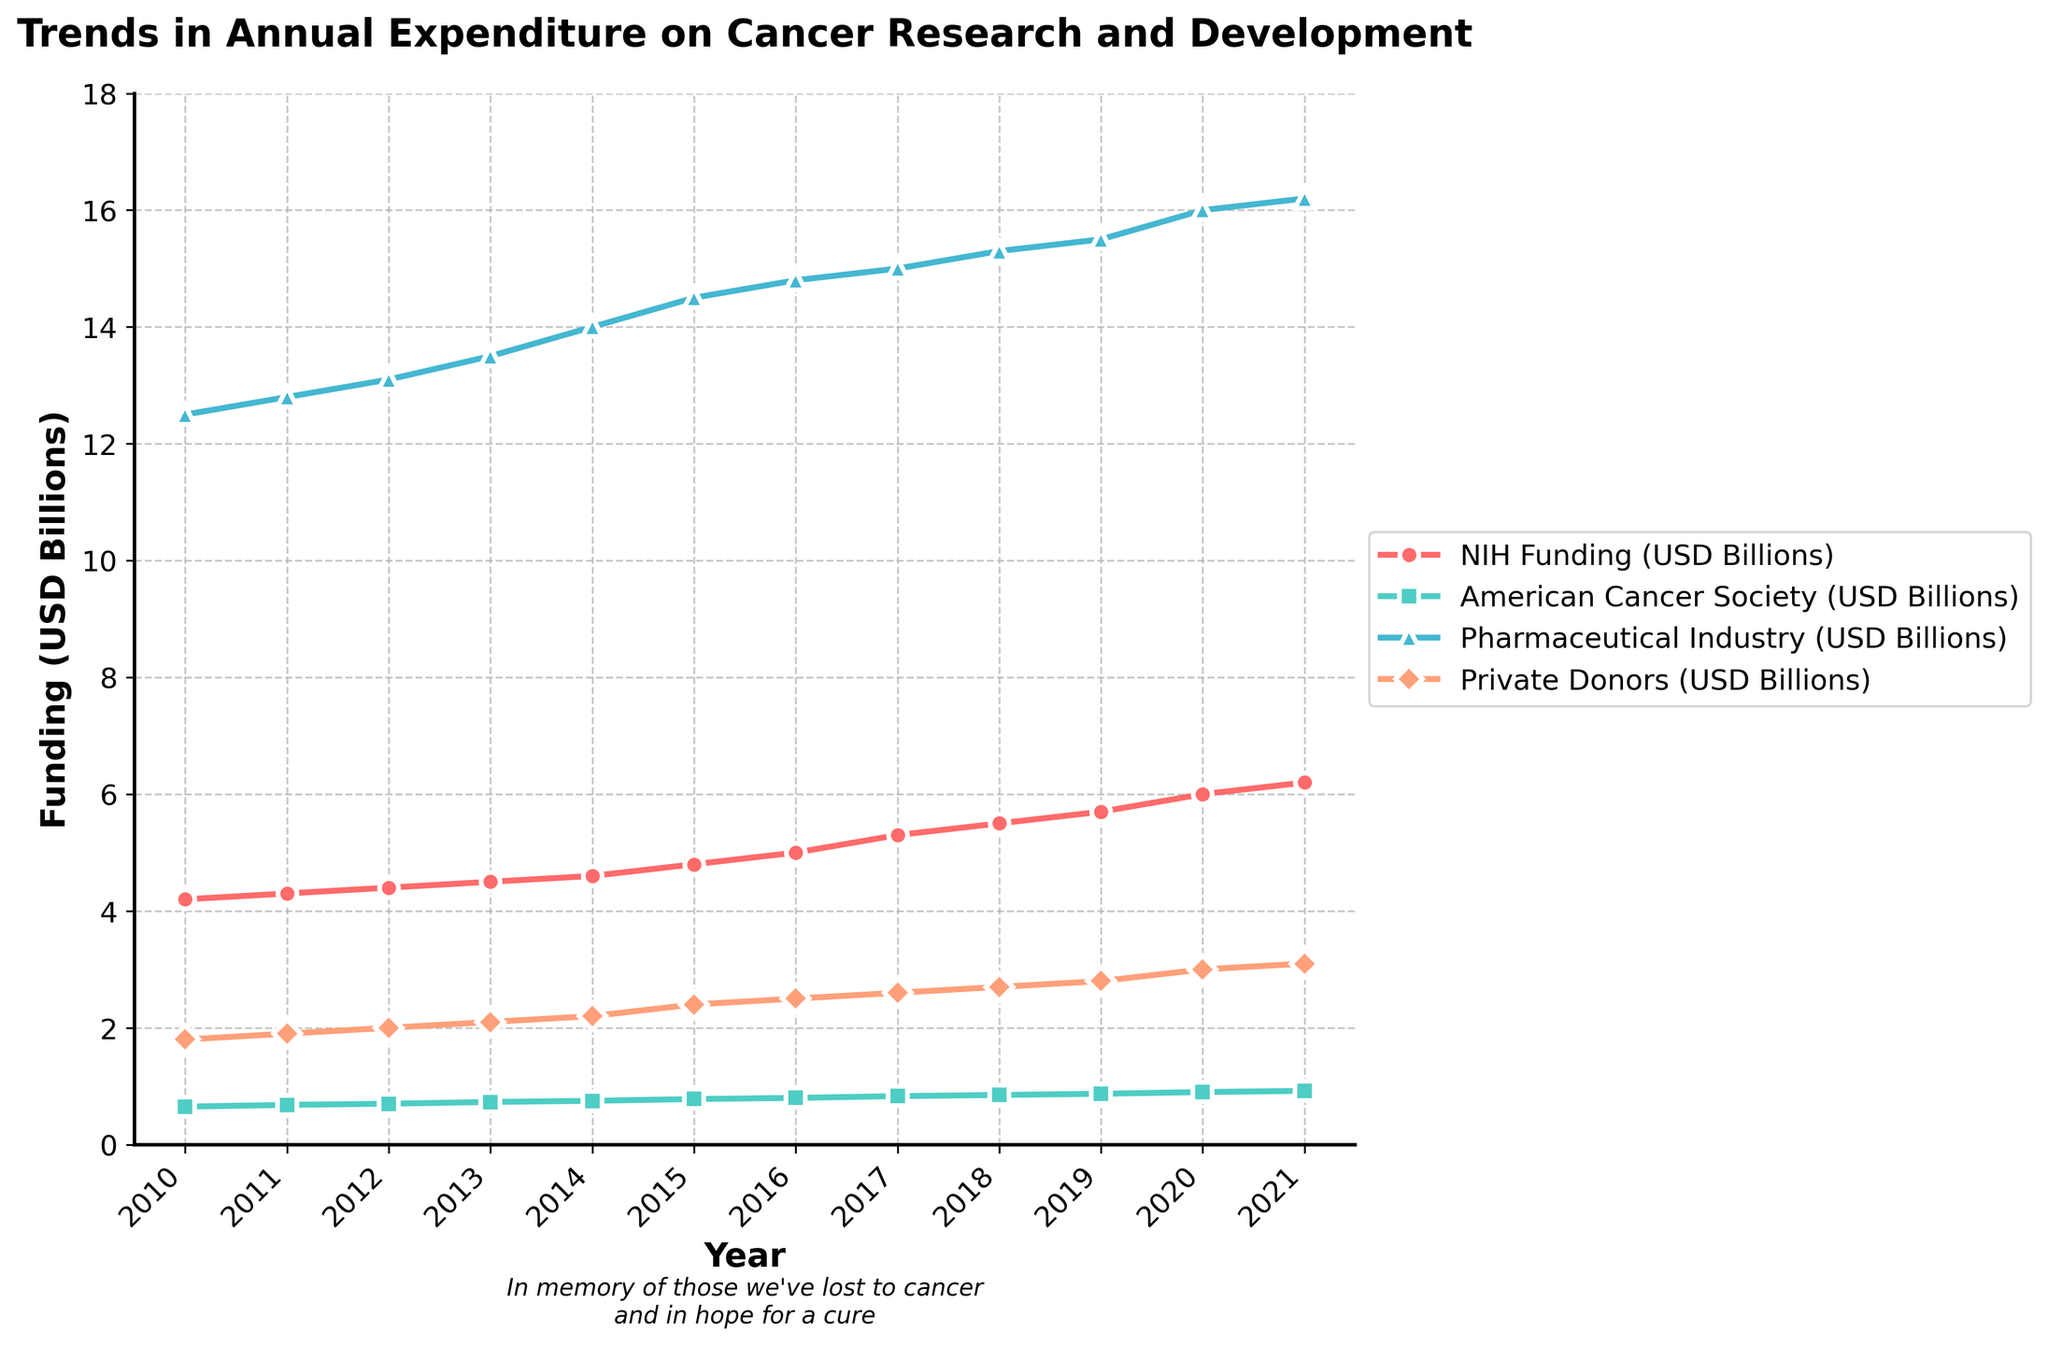What is the title of the plot? The title is located at the top of the plot in larger, bold text. It describes what the plot is about.
Answer: Trends in Annual Expenditure on Cancer Research and Development Which organization had the highest funding in 2019? By visually comparing the lines from the different organizations for the year 2019, we can see which one reaches the highest value on the y-axis.
Answer: Pharmaceutical Industry What was the NIH funding in 2010? We look at the plotted line for NIH Funding and trace it to the point where it intersects with the year 2010 on the x-axis. The corresponding value on the y-axis gives the answer.
Answer: 4.2 billion USD How did the funding from Private Donors change from 2010 to 2021? Locate the points for Private Donors funding in 2010 and 2021 on the y-axis, then calculate the difference between these two values.
Answer: Increased by 1.3 billion USD Compare the funding trends of NIH and the American Cancer Society. Which one has a steeper increase over the years? Look at the slopes of the lines for NIH and the American Cancer Society. The line with the steeper slope represents a faster rate of increase.
Answer: NIH What is the total funding from the Pharmaceutical Industry over the years shown in the plot? Add up the values for Pharmaceutical Industry funding across each year from 2010 to 2021.
Answer: 177.2 billion USD Which year had the smallest difference in funding between the NIH and the American Cancer Society? Calculate the differences between the NIH and American Cancer Society funding for each year and find the year with the smallest difference.
Answer: 2010 On average, how much did Private Donors contribute annually over the plotted years? Sum up the Private Donors funding values for each year and then divide by the number of years (12).
Answer: 2.42 billion USD In which year did the American Cancer Society first exceed 0.8 billion USD in funding? Look at the plotted line for the American Cancer Society and find the first year where the value on the y-axis exceeds 0.8 billion USD.
Answer: 2016 Has the overall trend of the Pharmaceutical Industry funding been consistent, increasing, or decreasing? Analyze the slope of the line for Pharmaceutical Industry funding from 2010 to 2021 to determine the overall trend.
Answer: Increasing 